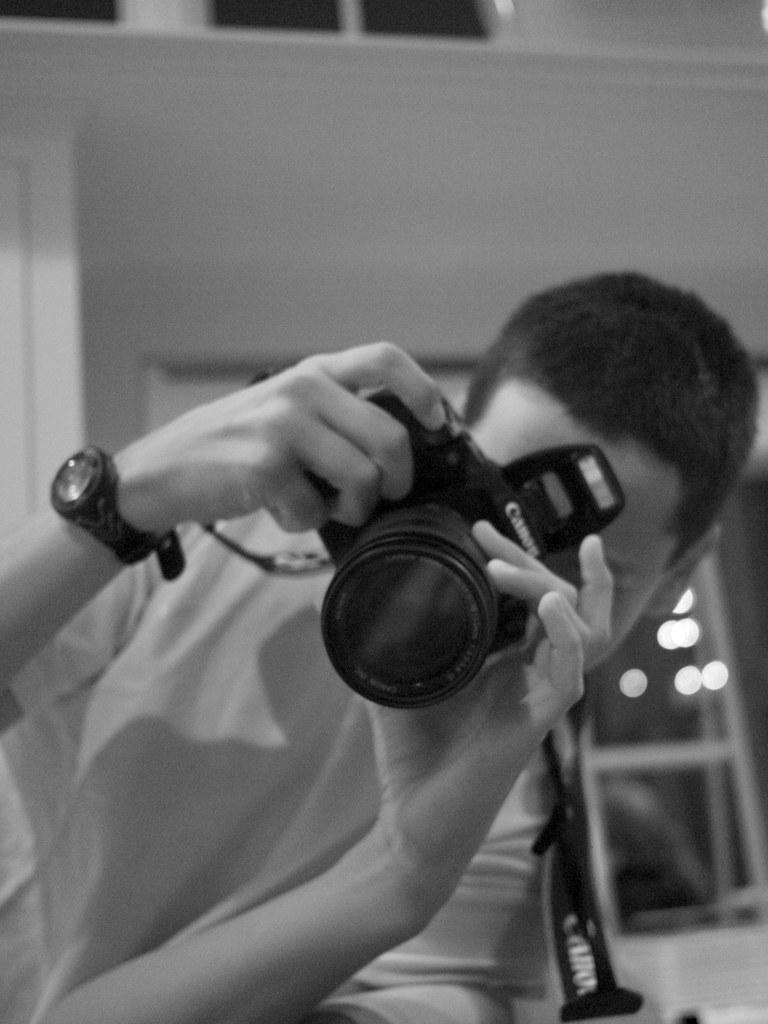Describe this image in one or two sentences. This looks like a black and white image. There is a man laying and holding canon camera with his hands. I can see a wrist watch wearing to his hand. 